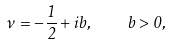Convert formula to latex. <formula><loc_0><loc_0><loc_500><loc_500>\nu = - \frac { 1 } { 2 } + i b , \quad b > 0 ,</formula> 